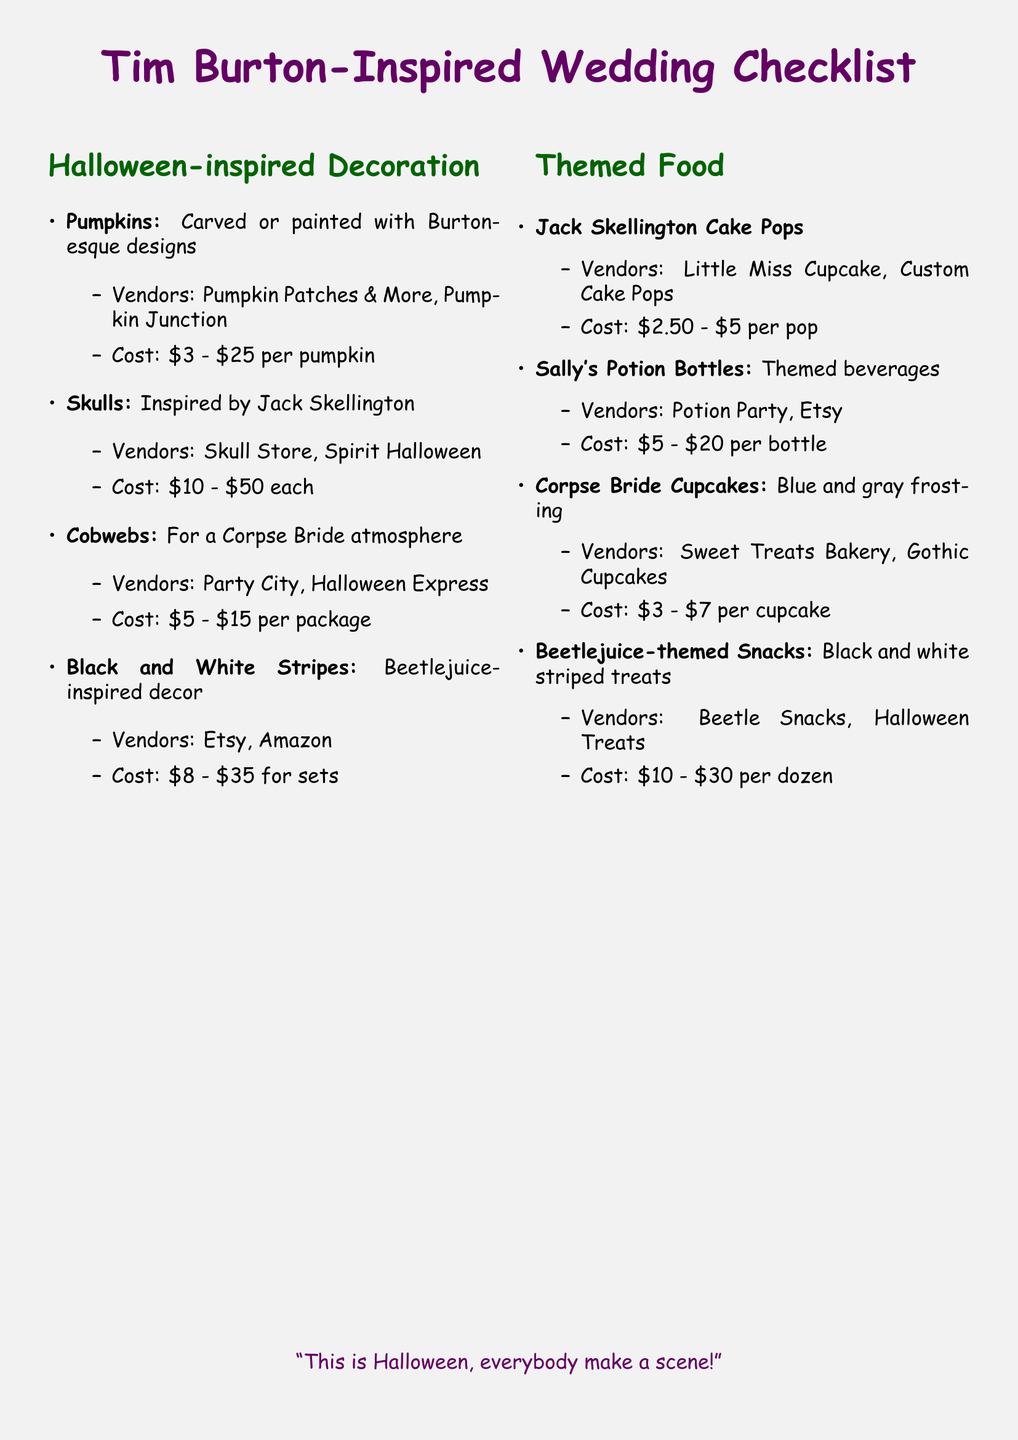what is the cost range for carved pumpkins? The cost range for carved pumpkins is listed alongside the decoration section in the document.
Answer: $3 - $25 per pumpkin which vendor provides skull decorations? The document lists vendors alongside each decoration item under the Halloween-inspired Decoration section.
Answer: Skull Store what inspired the cobweb decorations? The document specifies that the cobwebs are for creating a specific atmosphere related to a character.
Answer: Corpse Bride how much do Jack Skellington cake pops cost? The document includes cost estimates for themed food items, including Jack Skellington cake pops.
Answer: $2.50 - $5 per pop name one vendor for Sally's Potion Bottles. The document provides a list of vendors for themed food options.
Answer: Potion Party what decoration theme is inspired by Beetlejuice? The document mentions a specific decoration style related to the movie character.
Answer: Black and White Stripes how much do Corpse Bride cupcakes cost? The document outlines the pricing for specific themed food items.
Answer: $3 - $7 per cupcake which colored frosting is used for the Corpse Bride cupcakes? The document gives a description of the cupcakes in the themed food section.
Answer: Blue and gray what is the total cost range for Beetlejuice-themed snacks? The document specifies cost ranges for several themed food items.
Answer: $10 - $30 per dozen 